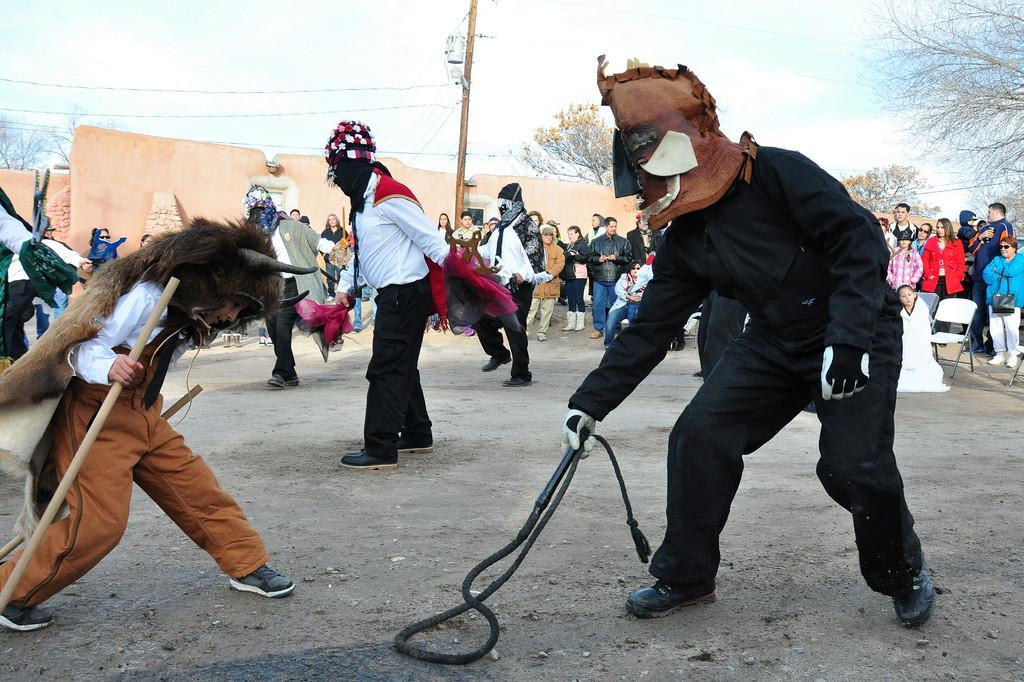Please provide a concise description of this image. In this image, we can see a crowd in front of the wall. There is a pole at the top of the image contains wires. There are some persons wearing fancy dresses. The person who is on the left side of the holding a stick with his hand. In the background of the image, there are trees and sky. 